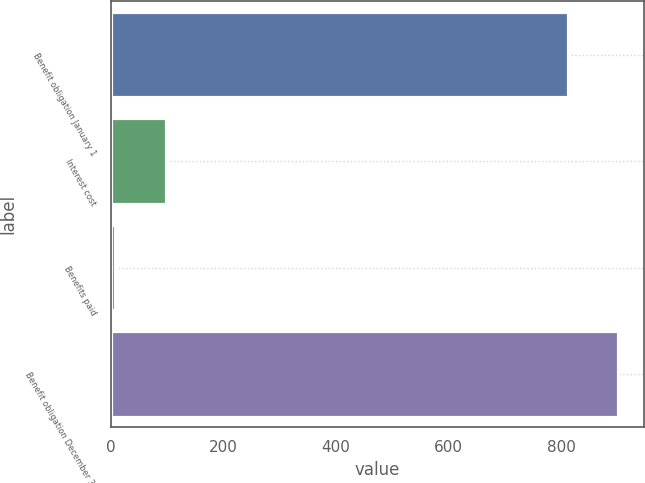Convert chart to OTSL. <chart><loc_0><loc_0><loc_500><loc_500><bar_chart><fcel>Benefit obligation January 1<fcel>Interest cost<fcel>Benefits paid<fcel>Benefit obligation December 31<nl><fcel>812<fcel>97.1<fcel>8<fcel>901.1<nl></chart> 